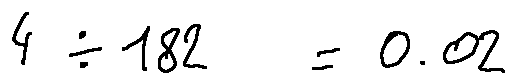Convert formula to latex. <formula><loc_0><loc_0><loc_500><loc_500>4 \div 1 8 2 = 0 . 0 2</formula> 